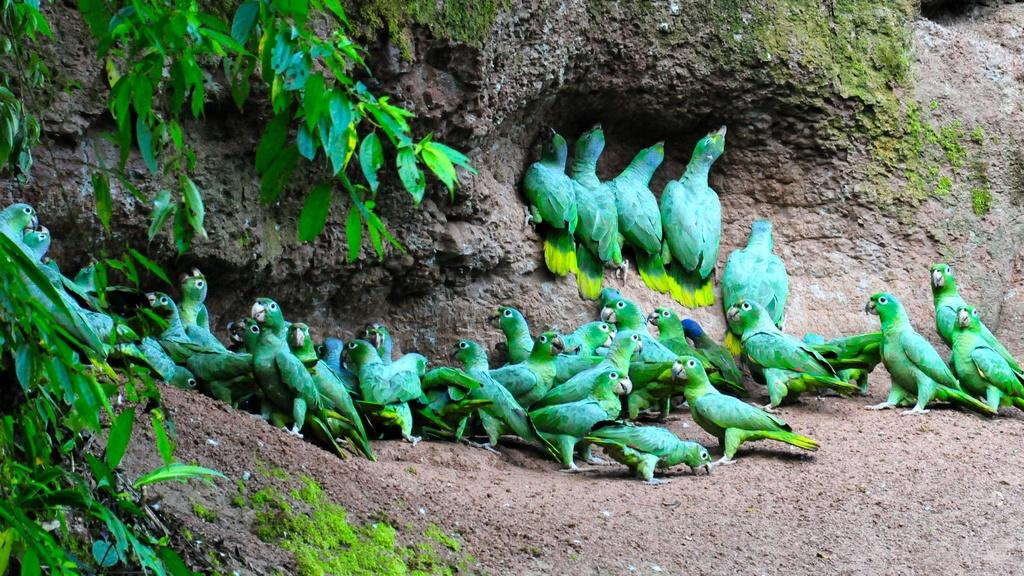What type of animals can be seen in the image? Birds can be seen in the image. What type of vegetation is present in the image? There are leaves with branches in the image. What type of flag is visible in the image? There is no flag present in the image. What time of day is it during the recess shown in the image? There is no indication of a recess or time of day in the image. 